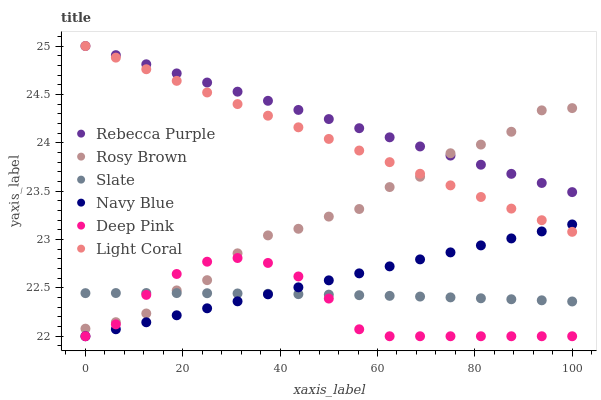Does Deep Pink have the minimum area under the curve?
Answer yes or no. Yes. Does Rebecca Purple have the maximum area under the curve?
Answer yes or no. Yes. Does Navy Blue have the minimum area under the curve?
Answer yes or no. No. Does Navy Blue have the maximum area under the curve?
Answer yes or no. No. Is Light Coral the smoothest?
Answer yes or no. Yes. Is Rosy Brown the roughest?
Answer yes or no. Yes. Is Navy Blue the smoothest?
Answer yes or no. No. Is Navy Blue the roughest?
Answer yes or no. No. Does Deep Pink have the lowest value?
Answer yes or no. Yes. Does Slate have the lowest value?
Answer yes or no. No. Does Rebecca Purple have the highest value?
Answer yes or no. Yes. Does Navy Blue have the highest value?
Answer yes or no. No. Is Slate less than Rebecca Purple?
Answer yes or no. Yes. Is Rebecca Purple greater than Slate?
Answer yes or no. Yes. Does Deep Pink intersect Rosy Brown?
Answer yes or no. Yes. Is Deep Pink less than Rosy Brown?
Answer yes or no. No. Is Deep Pink greater than Rosy Brown?
Answer yes or no. No. Does Slate intersect Rebecca Purple?
Answer yes or no. No. 